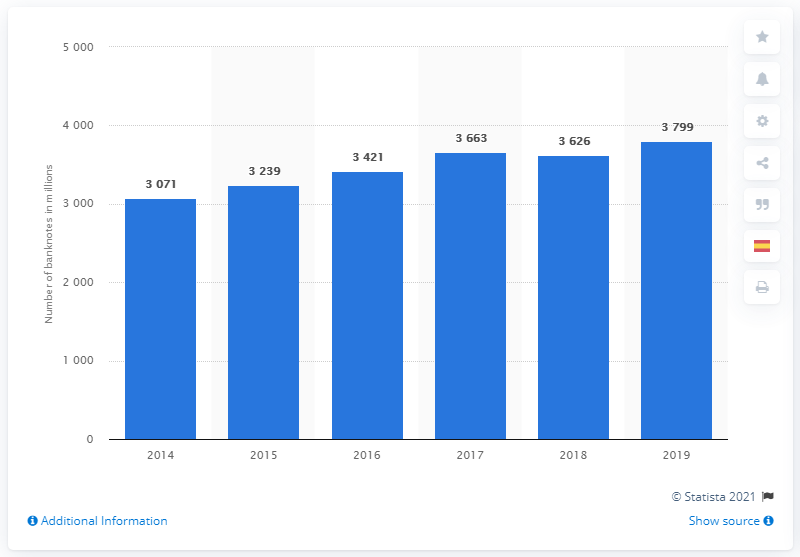Outline some significant characteristics in this image. In 2019, the highest number of British banknotes was produced. 